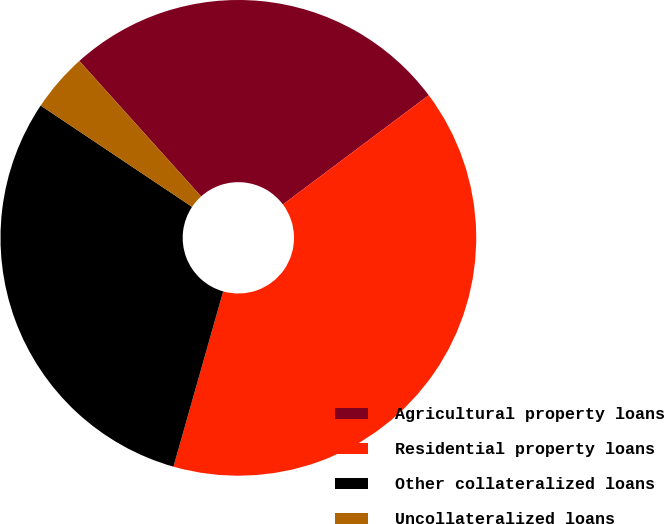Convert chart to OTSL. <chart><loc_0><loc_0><loc_500><loc_500><pie_chart><fcel>Agricultural property loans<fcel>Residential property loans<fcel>Other collateralized loans<fcel>Uncollateralized loans<nl><fcel>26.42%<fcel>39.63%<fcel>29.99%<fcel>3.96%<nl></chart> 